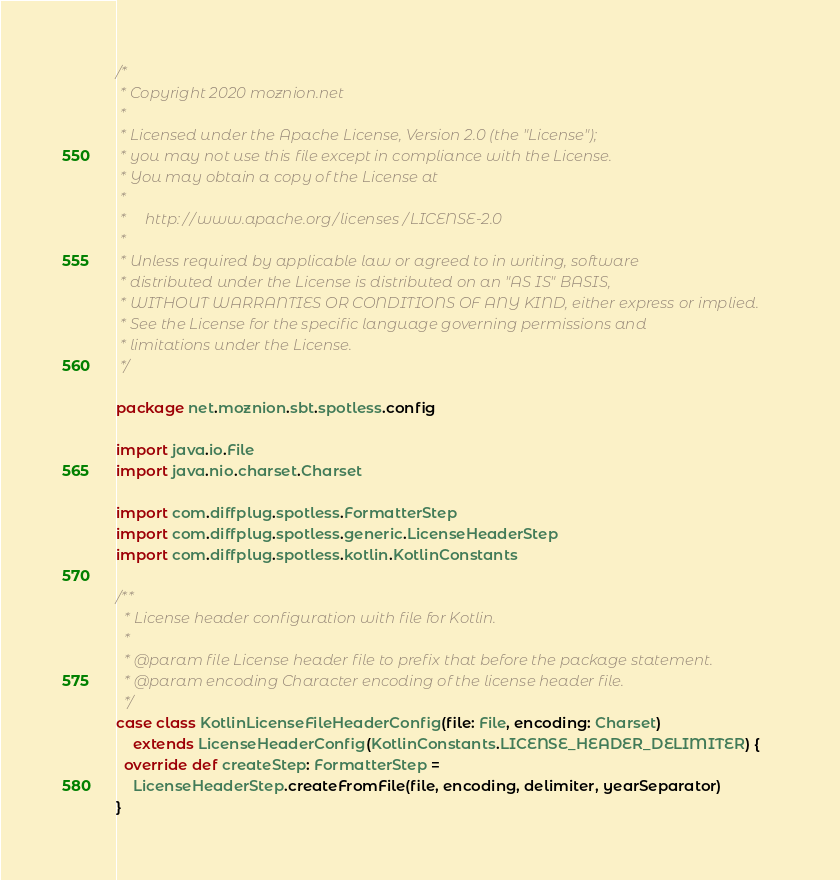<code> <loc_0><loc_0><loc_500><loc_500><_Scala_>/*
 * Copyright 2020 moznion.net
 *
 * Licensed under the Apache License, Version 2.0 (the "License");
 * you may not use this file except in compliance with the License.
 * You may obtain a copy of the License at
 *
 *     http://www.apache.org/licenses/LICENSE-2.0
 *
 * Unless required by applicable law or agreed to in writing, software
 * distributed under the License is distributed on an "AS IS" BASIS,
 * WITHOUT WARRANTIES OR CONDITIONS OF ANY KIND, either express or implied.
 * See the License for the specific language governing permissions and
 * limitations under the License.
 */

package net.moznion.sbt.spotless.config

import java.io.File
import java.nio.charset.Charset

import com.diffplug.spotless.FormatterStep
import com.diffplug.spotless.generic.LicenseHeaderStep
import com.diffplug.spotless.kotlin.KotlinConstants

/**
  * License header configuration with file for Kotlin.
  *
  * @param file License header file to prefix that before the package statement.
  * @param encoding Character encoding of the license header file.
  */
case class KotlinLicenseFileHeaderConfig(file: File, encoding: Charset)
    extends LicenseHeaderConfig(KotlinConstants.LICENSE_HEADER_DELIMITER) {
  override def createStep: FormatterStep =
    LicenseHeaderStep.createFromFile(file, encoding, delimiter, yearSeparator)
}
</code> 